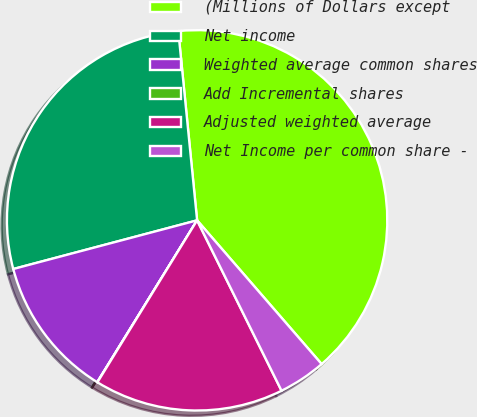Convert chart to OTSL. <chart><loc_0><loc_0><loc_500><loc_500><pie_chart><fcel>(Millions of Dollars except<fcel>Net income<fcel>Weighted average common shares<fcel>Add Incremental shares<fcel>Adjusted weighted average<fcel>Net Income per common share -<nl><fcel>40.21%<fcel>27.54%<fcel>12.08%<fcel>0.02%<fcel>16.1%<fcel>4.04%<nl></chart> 